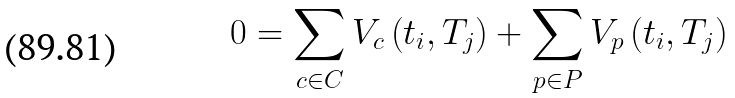<formula> <loc_0><loc_0><loc_500><loc_500>0 = \sum _ { c \in C } V _ { c } \left ( t _ { i } , T _ { j } \right ) + \sum _ { p \in P } V _ { p } \left ( t _ { i } , T _ { j } \right )</formula> 